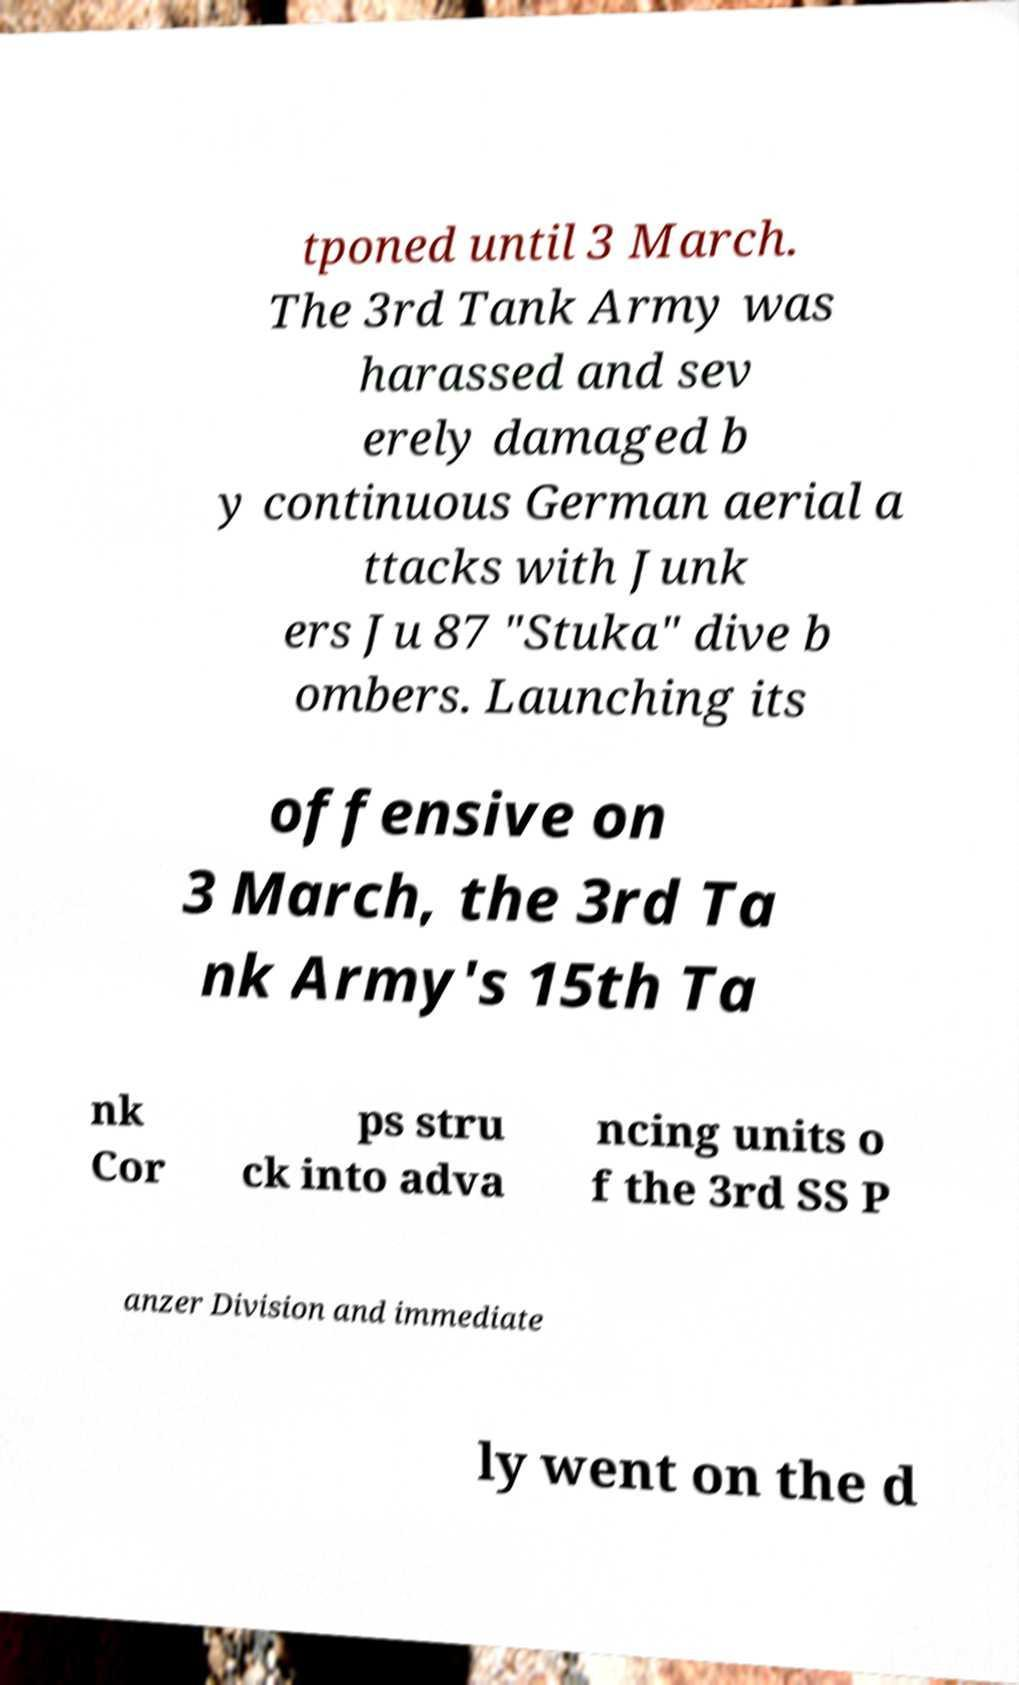Can you accurately transcribe the text from the provided image for me? tponed until 3 March. The 3rd Tank Army was harassed and sev erely damaged b y continuous German aerial a ttacks with Junk ers Ju 87 "Stuka" dive b ombers. Launching its offensive on 3 March, the 3rd Ta nk Army's 15th Ta nk Cor ps stru ck into adva ncing units o f the 3rd SS P anzer Division and immediate ly went on the d 